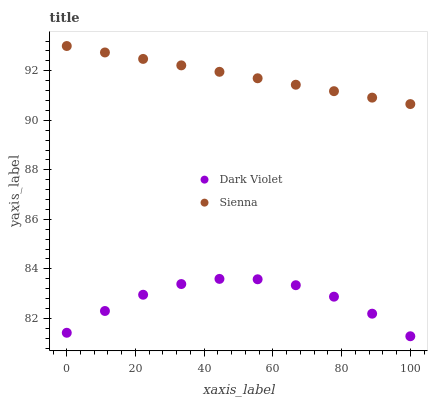Does Dark Violet have the minimum area under the curve?
Answer yes or no. Yes. Does Sienna have the maximum area under the curve?
Answer yes or no. Yes. Does Dark Violet have the maximum area under the curve?
Answer yes or no. No. Is Sienna the smoothest?
Answer yes or no. Yes. Is Dark Violet the roughest?
Answer yes or no. Yes. Is Dark Violet the smoothest?
Answer yes or no. No. Does Dark Violet have the lowest value?
Answer yes or no. Yes. Does Sienna have the highest value?
Answer yes or no. Yes. Does Dark Violet have the highest value?
Answer yes or no. No. Is Dark Violet less than Sienna?
Answer yes or no. Yes. Is Sienna greater than Dark Violet?
Answer yes or no. Yes. Does Dark Violet intersect Sienna?
Answer yes or no. No. 